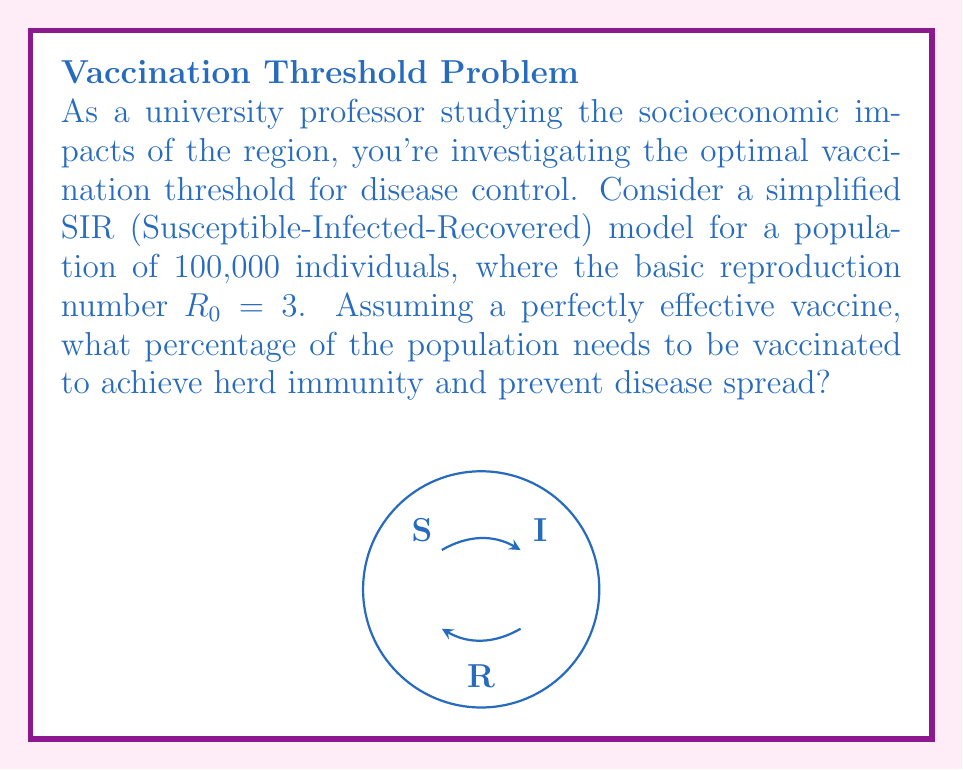Provide a solution to this math problem. To solve this problem, we'll use the concept of herd immunity threshold in the SIR model:

1) The herd immunity threshold (HIT) is given by the formula:

   $$ HIT = 1 - \frac{1}{R_0} $$

   where $R_0$ is the basic reproduction number.

2) We're given that $R_0 = 3$. Let's substitute this into our equation:

   $$ HIT = 1 - \frac{1}{3} $$

3) Simplify:
   $$ HIT = \frac{3}{3} - \frac{1}{3} = \frac{2}{3} $$

4) Convert to a percentage:
   $$ HIT = \frac{2}{3} \times 100\% = 66.67\% $$

5) Therefore, approximately 66.67% of the population needs to be vaccinated to achieve herd immunity.

This threshold ensures that, on average, each infected individual will infect less than one other person, causing the outbreak to decline and eventually stop.
Answer: 66.67% 